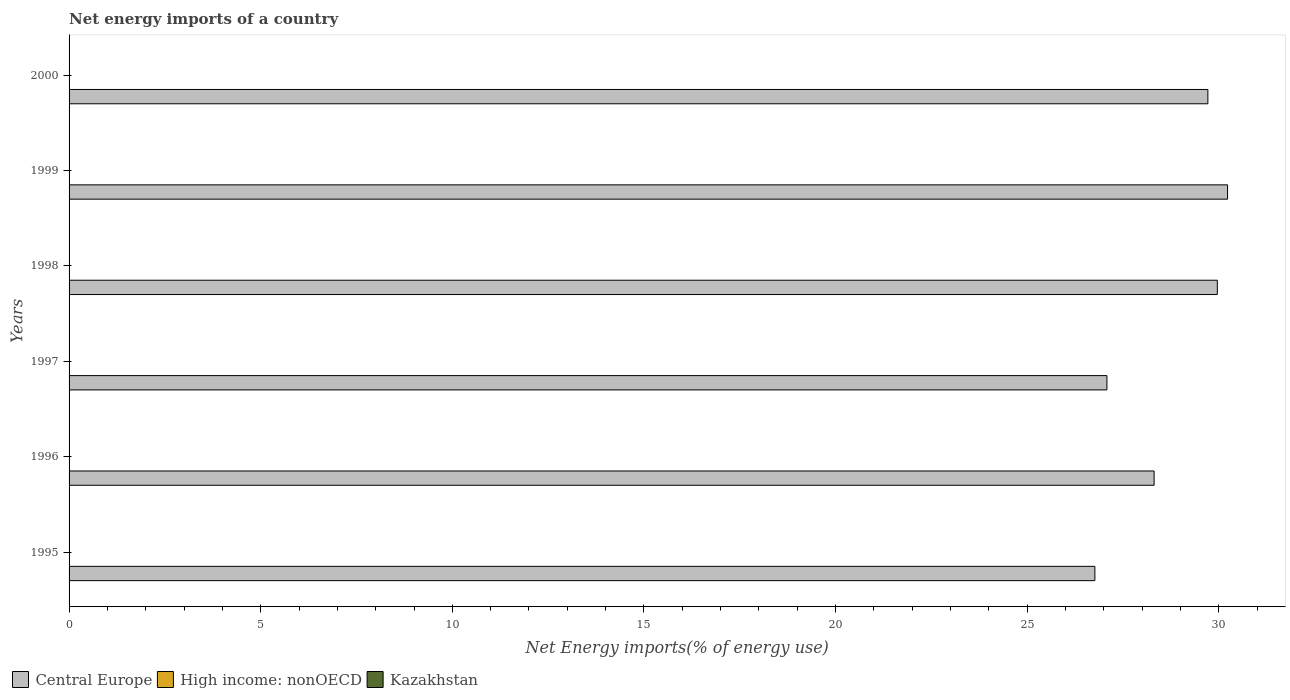How many bars are there on the 4th tick from the top?
Your response must be concise. 1. How many bars are there on the 1st tick from the bottom?
Offer a very short reply. 1. What is the label of the 2nd group of bars from the top?
Ensure brevity in your answer.  1999. What is the net energy imports in Central Europe in 1997?
Offer a very short reply. 27.08. Across all years, what is the maximum net energy imports in Central Europe?
Your response must be concise. 30.23. Across all years, what is the minimum net energy imports in Central Europe?
Your answer should be very brief. 26.77. In which year was the net energy imports in Central Europe maximum?
Your answer should be compact. 1999. What is the total net energy imports in High income: nonOECD in the graph?
Ensure brevity in your answer.  0. What is the difference between the net energy imports in Central Europe in 1999 and that in 2000?
Your answer should be very brief. 0.51. What is the difference between the net energy imports in Central Europe in 2000 and the net energy imports in High income: nonOECD in 1997?
Your answer should be very brief. 29.71. What is the average net energy imports in Kazakhstan per year?
Offer a terse response. 0. In how many years, is the net energy imports in Kazakhstan greater than 13 %?
Offer a very short reply. 0. What is the ratio of the net energy imports in Central Europe in 1995 to that in 1997?
Provide a succinct answer. 0.99. Is the net energy imports in Central Europe in 1998 less than that in 2000?
Provide a short and direct response. No. What is the difference between the highest and the second highest net energy imports in Central Europe?
Ensure brevity in your answer.  0.27. What is the difference between the highest and the lowest net energy imports in Central Europe?
Your response must be concise. 3.46. In how many years, is the net energy imports in High income: nonOECD greater than the average net energy imports in High income: nonOECD taken over all years?
Provide a succinct answer. 0. Is the sum of the net energy imports in Central Europe in 1995 and 1996 greater than the maximum net energy imports in Kazakhstan across all years?
Offer a terse response. Yes. Is it the case that in every year, the sum of the net energy imports in High income: nonOECD and net energy imports in Kazakhstan is greater than the net energy imports in Central Europe?
Your answer should be very brief. No. How many bars are there?
Keep it short and to the point. 6. How many legend labels are there?
Your response must be concise. 3. How are the legend labels stacked?
Offer a terse response. Horizontal. What is the title of the graph?
Offer a terse response. Net energy imports of a country. Does "OECD members" appear as one of the legend labels in the graph?
Your answer should be compact. No. What is the label or title of the X-axis?
Offer a very short reply. Net Energy imports(% of energy use). What is the Net Energy imports(% of energy use) in Central Europe in 1995?
Ensure brevity in your answer.  26.77. What is the Net Energy imports(% of energy use) in Kazakhstan in 1995?
Offer a terse response. 0. What is the Net Energy imports(% of energy use) in Central Europe in 1996?
Your answer should be very brief. 28.31. What is the Net Energy imports(% of energy use) of High income: nonOECD in 1996?
Offer a terse response. 0. What is the Net Energy imports(% of energy use) in Kazakhstan in 1996?
Offer a very short reply. 0. What is the Net Energy imports(% of energy use) in Central Europe in 1997?
Make the answer very short. 27.08. What is the Net Energy imports(% of energy use) of Central Europe in 1998?
Make the answer very short. 29.96. What is the Net Energy imports(% of energy use) in High income: nonOECD in 1998?
Offer a very short reply. 0. What is the Net Energy imports(% of energy use) of Central Europe in 1999?
Your answer should be very brief. 30.23. What is the Net Energy imports(% of energy use) of High income: nonOECD in 1999?
Give a very brief answer. 0. What is the Net Energy imports(% of energy use) in Central Europe in 2000?
Provide a short and direct response. 29.71. Across all years, what is the maximum Net Energy imports(% of energy use) of Central Europe?
Offer a very short reply. 30.23. Across all years, what is the minimum Net Energy imports(% of energy use) of Central Europe?
Offer a terse response. 26.77. What is the total Net Energy imports(% of energy use) in Central Europe in the graph?
Provide a succinct answer. 172.06. What is the difference between the Net Energy imports(% of energy use) of Central Europe in 1995 and that in 1996?
Your answer should be very brief. -1.55. What is the difference between the Net Energy imports(% of energy use) in Central Europe in 1995 and that in 1997?
Make the answer very short. -0.31. What is the difference between the Net Energy imports(% of energy use) of Central Europe in 1995 and that in 1998?
Ensure brevity in your answer.  -3.2. What is the difference between the Net Energy imports(% of energy use) of Central Europe in 1995 and that in 1999?
Your response must be concise. -3.46. What is the difference between the Net Energy imports(% of energy use) of Central Europe in 1995 and that in 2000?
Offer a terse response. -2.95. What is the difference between the Net Energy imports(% of energy use) in Central Europe in 1996 and that in 1997?
Provide a succinct answer. 1.23. What is the difference between the Net Energy imports(% of energy use) of Central Europe in 1996 and that in 1998?
Your answer should be very brief. -1.65. What is the difference between the Net Energy imports(% of energy use) in Central Europe in 1996 and that in 1999?
Provide a succinct answer. -1.92. What is the difference between the Net Energy imports(% of energy use) in Central Europe in 1996 and that in 2000?
Make the answer very short. -1.4. What is the difference between the Net Energy imports(% of energy use) of Central Europe in 1997 and that in 1998?
Give a very brief answer. -2.88. What is the difference between the Net Energy imports(% of energy use) in Central Europe in 1997 and that in 1999?
Ensure brevity in your answer.  -3.15. What is the difference between the Net Energy imports(% of energy use) in Central Europe in 1997 and that in 2000?
Offer a terse response. -2.63. What is the difference between the Net Energy imports(% of energy use) in Central Europe in 1998 and that in 1999?
Make the answer very short. -0.27. What is the difference between the Net Energy imports(% of energy use) in Central Europe in 1998 and that in 2000?
Your answer should be very brief. 0.25. What is the difference between the Net Energy imports(% of energy use) in Central Europe in 1999 and that in 2000?
Your response must be concise. 0.51. What is the average Net Energy imports(% of energy use) of Central Europe per year?
Provide a succinct answer. 28.68. What is the ratio of the Net Energy imports(% of energy use) of Central Europe in 1995 to that in 1996?
Your answer should be compact. 0.95. What is the ratio of the Net Energy imports(% of energy use) in Central Europe in 1995 to that in 1997?
Your answer should be compact. 0.99. What is the ratio of the Net Energy imports(% of energy use) in Central Europe in 1995 to that in 1998?
Ensure brevity in your answer.  0.89. What is the ratio of the Net Energy imports(% of energy use) in Central Europe in 1995 to that in 1999?
Make the answer very short. 0.89. What is the ratio of the Net Energy imports(% of energy use) in Central Europe in 1995 to that in 2000?
Your response must be concise. 0.9. What is the ratio of the Net Energy imports(% of energy use) of Central Europe in 1996 to that in 1997?
Make the answer very short. 1.05. What is the ratio of the Net Energy imports(% of energy use) of Central Europe in 1996 to that in 1998?
Give a very brief answer. 0.94. What is the ratio of the Net Energy imports(% of energy use) in Central Europe in 1996 to that in 1999?
Your answer should be very brief. 0.94. What is the ratio of the Net Energy imports(% of energy use) in Central Europe in 1996 to that in 2000?
Your answer should be very brief. 0.95. What is the ratio of the Net Energy imports(% of energy use) of Central Europe in 1997 to that in 1998?
Make the answer very short. 0.9. What is the ratio of the Net Energy imports(% of energy use) of Central Europe in 1997 to that in 1999?
Your answer should be very brief. 0.9. What is the ratio of the Net Energy imports(% of energy use) of Central Europe in 1997 to that in 2000?
Your answer should be compact. 0.91. What is the ratio of the Net Energy imports(% of energy use) of Central Europe in 1998 to that in 1999?
Your response must be concise. 0.99. What is the ratio of the Net Energy imports(% of energy use) in Central Europe in 1998 to that in 2000?
Your answer should be compact. 1.01. What is the ratio of the Net Energy imports(% of energy use) of Central Europe in 1999 to that in 2000?
Provide a succinct answer. 1.02. What is the difference between the highest and the second highest Net Energy imports(% of energy use) of Central Europe?
Your answer should be very brief. 0.27. What is the difference between the highest and the lowest Net Energy imports(% of energy use) of Central Europe?
Give a very brief answer. 3.46. 